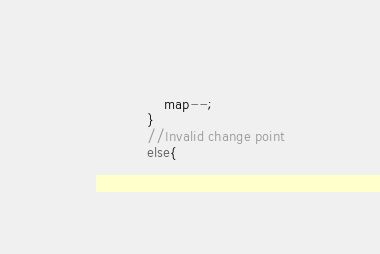<code> <loc_0><loc_0><loc_500><loc_500><_C_>				map--;
			}
			//Invalid change point
			else{</code> 